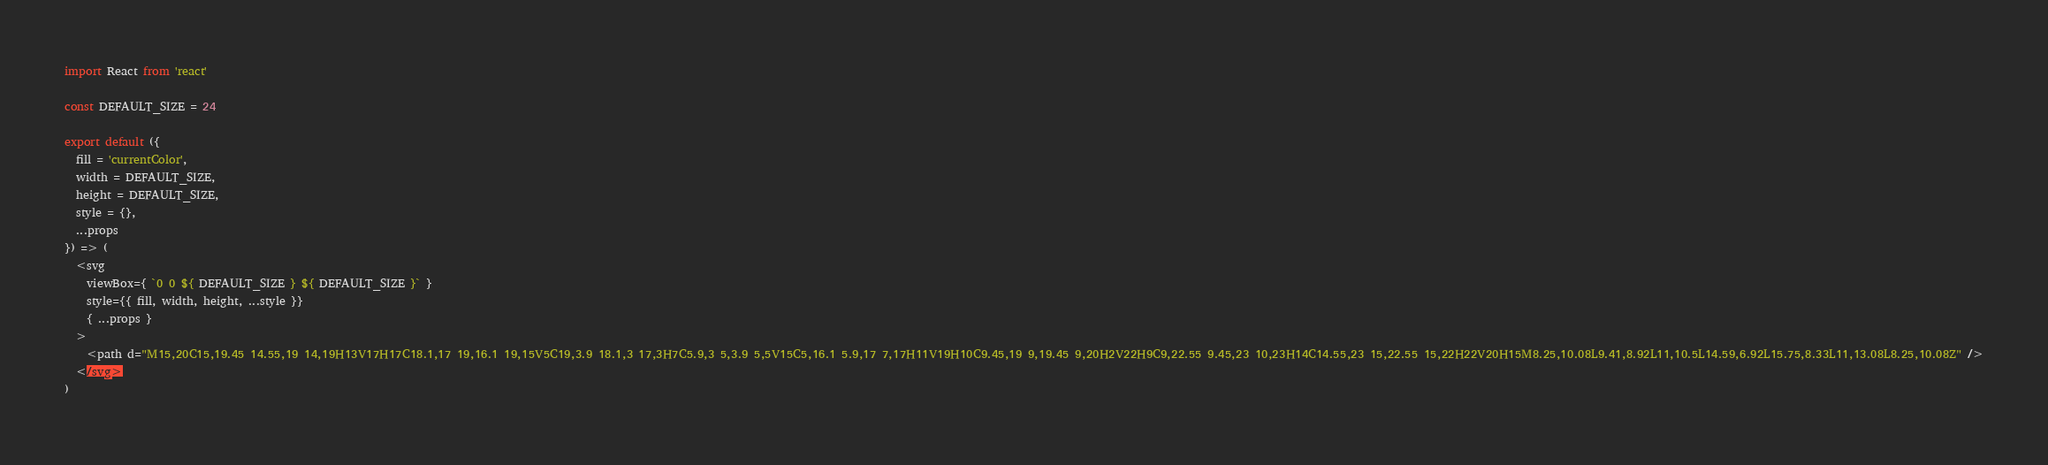Convert code to text. <code><loc_0><loc_0><loc_500><loc_500><_JavaScript_>import React from 'react'

const DEFAULT_SIZE = 24

export default ({
  fill = 'currentColor',
  width = DEFAULT_SIZE,
  height = DEFAULT_SIZE,
  style = {},
  ...props
}) => (
  <svg
    viewBox={ `0 0 ${ DEFAULT_SIZE } ${ DEFAULT_SIZE }` }
    style={{ fill, width, height, ...style }}
    { ...props }
  >
    <path d="M15,20C15,19.45 14.55,19 14,19H13V17H17C18.1,17 19,16.1 19,15V5C19,3.9 18.1,3 17,3H7C5.9,3 5,3.9 5,5V15C5,16.1 5.9,17 7,17H11V19H10C9.45,19 9,19.45 9,20H2V22H9C9,22.55 9.45,23 10,23H14C14.55,23 15,22.55 15,22H22V20H15M8.25,10.08L9.41,8.92L11,10.5L14.59,6.92L15.75,8.33L11,13.08L8.25,10.08Z" />
  </svg>
)
</code> 